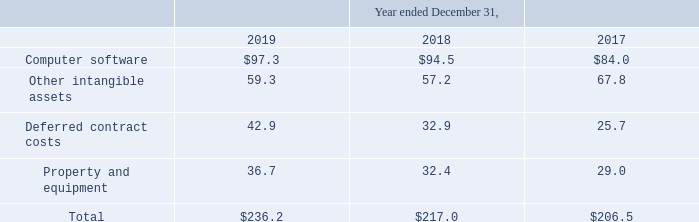Depreciation and Amortization
Depreciation and amortization includes the following (in millions):
Computer software amortization for the year ended December 31, 2018 includes accelerated amortization of $1.7 million related to certain internally developed software. Deferred contract costs amortization for the years ended December 31, 2019, 2018 and 2017 includes accelerated amortization of $6.2 million, $3.4 million and $3.3 million, respectively.
What was the amount of accelerated amortization included in Computer software amortization for the year ended 2018?
Answer scale should be: million. 1.7. What was the depreciation and amortization of computer software in 2017?
Answer scale should be: million. 84.0. What was the depreciation and amortization of deferred contract costs in 2019?
Answer scale should be: million. 42.9. What was the change in property and equipment between 2017 and 2018?
Answer scale should be: million. 32.4-29.0
Answer: 3.4. Which years did Deferred contract costs exceed $30 million? (2019:42.9),(2018:32.9)
Answer: 2019, 2018. What was the percentage change in the total depreciation and amortization between 2018 and 2019?
Answer scale should be: percent. (236.2-217.0)/217.0
Answer: 8.85. 